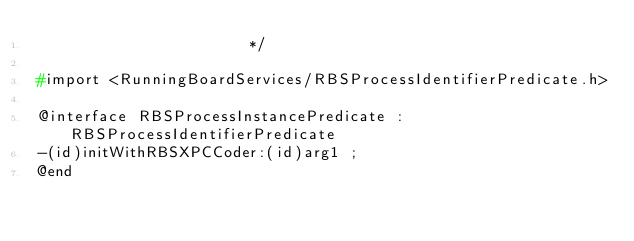<code> <loc_0><loc_0><loc_500><loc_500><_C_>                       */

#import <RunningBoardServices/RBSProcessIdentifierPredicate.h>

@interface RBSProcessInstancePredicate : RBSProcessIdentifierPredicate
-(id)initWithRBSXPCCoder:(id)arg1 ;
@end

</code> 